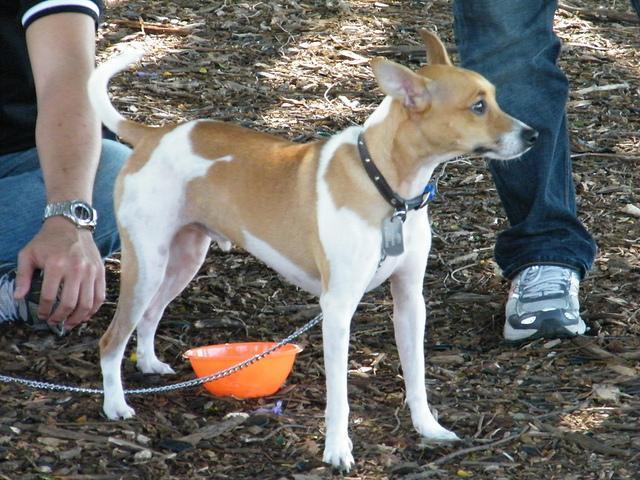How many dogs are shown?
Give a very brief answer. 1. How many people can be seen?
Give a very brief answer. 2. 